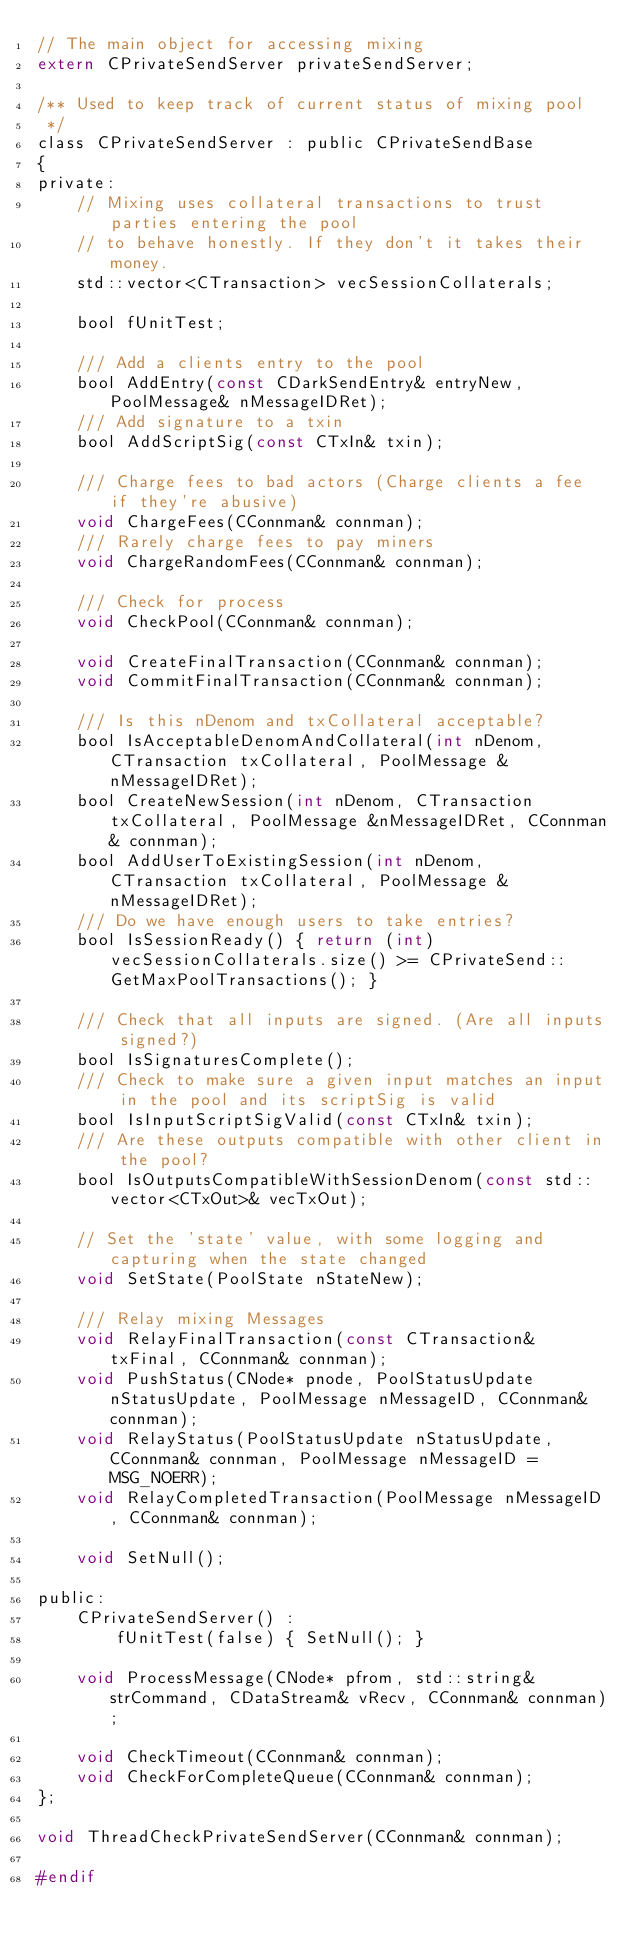Convert code to text. <code><loc_0><loc_0><loc_500><loc_500><_C_>// The main object for accessing mixing
extern CPrivateSendServer privateSendServer;

/** Used to keep track of current status of mixing pool
 */
class CPrivateSendServer : public CPrivateSendBase
{
private:
    // Mixing uses collateral transactions to trust parties entering the pool
    // to behave honestly. If they don't it takes their money.
    std::vector<CTransaction> vecSessionCollaterals;

    bool fUnitTest;

    /// Add a clients entry to the pool
    bool AddEntry(const CDarkSendEntry& entryNew, PoolMessage& nMessageIDRet);
    /// Add signature to a txin
    bool AddScriptSig(const CTxIn& txin);

    /// Charge fees to bad actors (Charge clients a fee if they're abusive)
    void ChargeFees(CConnman& connman);
    /// Rarely charge fees to pay miners
    void ChargeRandomFees(CConnman& connman);

    /// Check for process
    void CheckPool(CConnman& connman);

    void CreateFinalTransaction(CConnman& connman);
    void CommitFinalTransaction(CConnman& connman);

    /// Is this nDenom and txCollateral acceptable?
    bool IsAcceptableDenomAndCollateral(int nDenom, CTransaction txCollateral, PoolMessage &nMessageIDRet);
    bool CreateNewSession(int nDenom, CTransaction txCollateral, PoolMessage &nMessageIDRet, CConnman& connman);
    bool AddUserToExistingSession(int nDenom, CTransaction txCollateral, PoolMessage &nMessageIDRet);
    /// Do we have enough users to take entries?
    bool IsSessionReady() { return (int)vecSessionCollaterals.size() >= CPrivateSend::GetMaxPoolTransactions(); }

    /// Check that all inputs are signed. (Are all inputs signed?)
    bool IsSignaturesComplete();
    /// Check to make sure a given input matches an input in the pool and its scriptSig is valid
    bool IsInputScriptSigValid(const CTxIn& txin);
    /// Are these outputs compatible with other client in the pool?
    bool IsOutputsCompatibleWithSessionDenom(const std::vector<CTxOut>& vecTxOut);

    // Set the 'state' value, with some logging and capturing when the state changed
    void SetState(PoolState nStateNew);

    /// Relay mixing Messages
    void RelayFinalTransaction(const CTransaction& txFinal, CConnman& connman);
    void PushStatus(CNode* pnode, PoolStatusUpdate nStatusUpdate, PoolMessage nMessageID, CConnman& connman);
    void RelayStatus(PoolStatusUpdate nStatusUpdate, CConnman& connman, PoolMessage nMessageID = MSG_NOERR);
    void RelayCompletedTransaction(PoolMessage nMessageID, CConnman& connman);

    void SetNull();

public:
    CPrivateSendServer() :
        fUnitTest(false) { SetNull(); }

    void ProcessMessage(CNode* pfrom, std::string& strCommand, CDataStream& vRecv, CConnman& connman);

    void CheckTimeout(CConnman& connman);
    void CheckForCompleteQueue(CConnman& connman);
};

void ThreadCheckPrivateSendServer(CConnman& connman);

#endif
</code> 